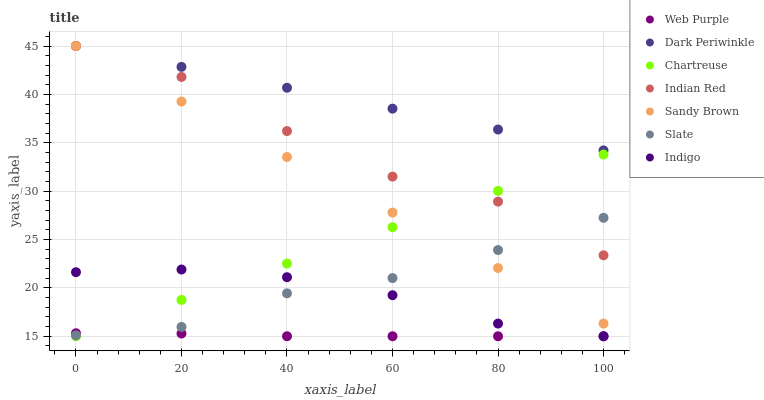Does Web Purple have the minimum area under the curve?
Answer yes or no. Yes. Does Dark Periwinkle have the maximum area under the curve?
Answer yes or no. Yes. Does Slate have the minimum area under the curve?
Answer yes or no. No. Does Slate have the maximum area under the curve?
Answer yes or no. No. Is Sandy Brown the smoothest?
Answer yes or no. Yes. Is Indian Red the roughest?
Answer yes or no. Yes. Is Slate the smoothest?
Answer yes or no. No. Is Slate the roughest?
Answer yes or no. No. Does Indigo have the lowest value?
Answer yes or no. Yes. Does Slate have the lowest value?
Answer yes or no. No. Does Dark Periwinkle have the highest value?
Answer yes or no. Yes. Does Slate have the highest value?
Answer yes or no. No. Is Web Purple less than Sandy Brown?
Answer yes or no. Yes. Is Sandy Brown greater than Web Purple?
Answer yes or no. Yes. Does Slate intersect Indian Red?
Answer yes or no. Yes. Is Slate less than Indian Red?
Answer yes or no. No. Is Slate greater than Indian Red?
Answer yes or no. No. Does Web Purple intersect Sandy Brown?
Answer yes or no. No. 